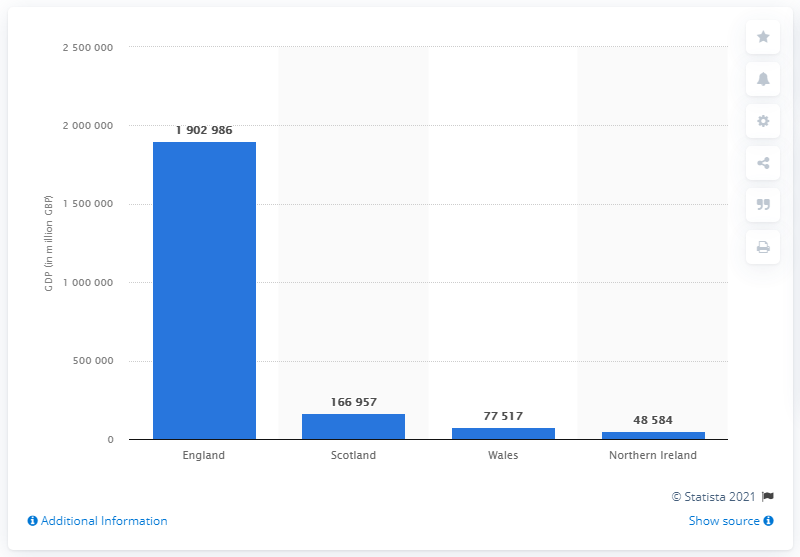Indicate a few pertinent items in this graphic. England's Gross Domestic Product in 2019 was 190,298,633. In 2019, Scotland's Gross Domestic Product (GDP) was 166,957 million US dollars. 